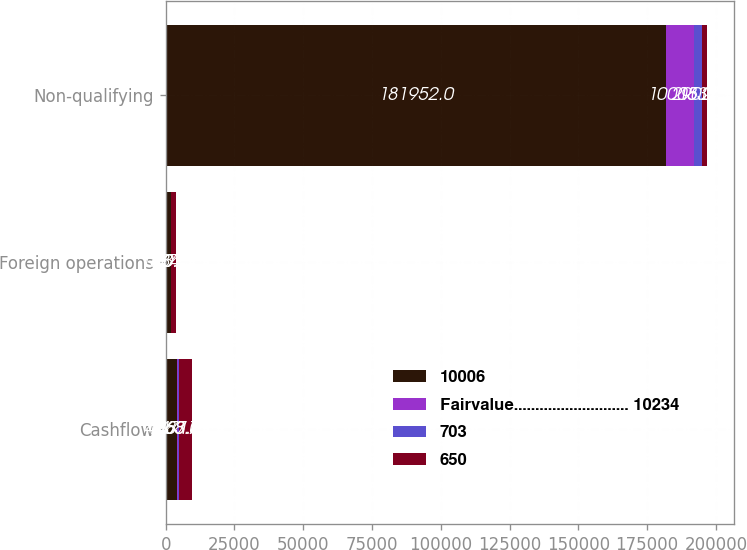Convert chart to OTSL. <chart><loc_0><loc_0><loc_500><loc_500><stacked_bar_chart><ecel><fcel>Cashflow<fcel>Foreign operations<fcel>Non-qualifying<nl><fcel>10006<fcel>4068<fcel>1834<fcel>181952<nl><fcel>Fairvalue........................... 10234<fcel>463<fcel>33<fcel>10005<nl><fcel>703<fcel>387<fcel>50<fcel>2902<nl><fcel>650<fcel>4717<fcel>1674<fcel>1834<nl></chart> 